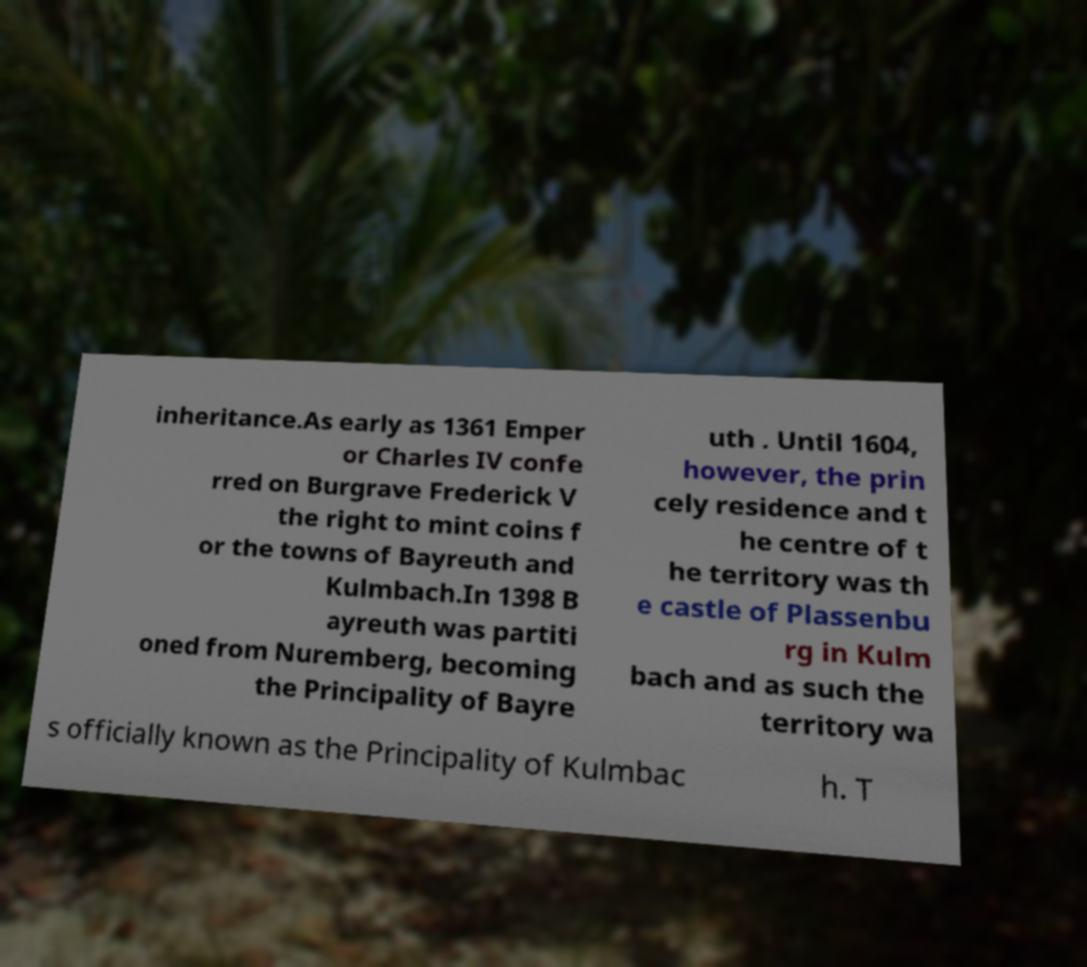For documentation purposes, I need the text within this image transcribed. Could you provide that? inheritance.As early as 1361 Emper or Charles IV confe rred on Burgrave Frederick V the right to mint coins f or the towns of Bayreuth and Kulmbach.In 1398 B ayreuth was partiti oned from Nuremberg, becoming the Principality of Bayre uth . Until 1604, however, the prin cely residence and t he centre of t he territory was th e castle of Plassenbu rg in Kulm bach and as such the territory wa s officially known as the Principality of Kulmbac h. T 